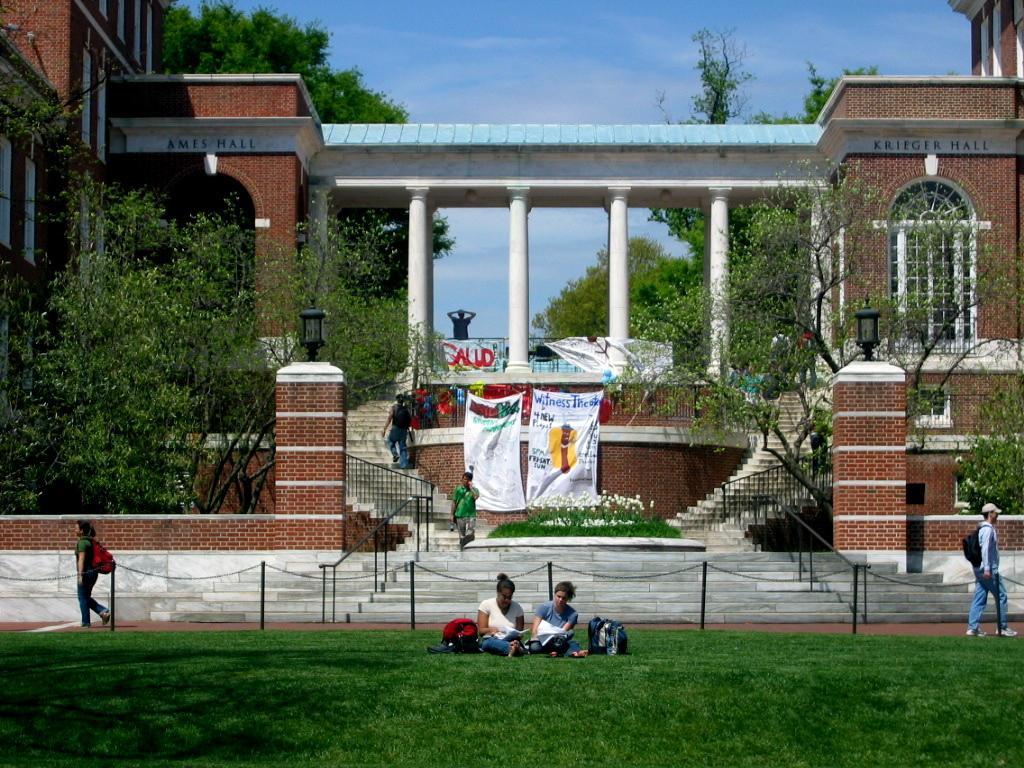How would you summarize this image in a sentence or two? In front of the image there are two people with bags are sitting on the grass surface, behind them there is a chain metal rod fence and there are a few people walking on the pavement and on the stairs, besides the stairs there is a metal rod fence and there are two lamps on the brick wall and there are trees, banners on the building and there is some text on the building. 